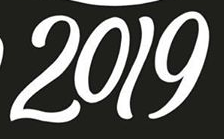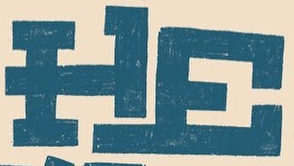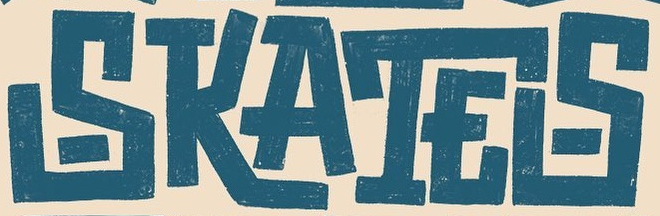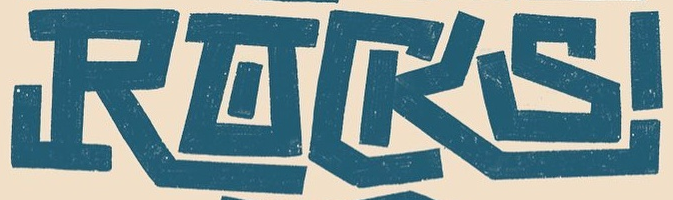What words can you see in these images in sequence, separated by a semicolon? 2019; HE; SKATES; RACKS 